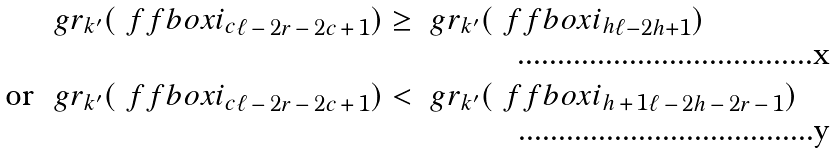<formula> <loc_0><loc_0><loc_500><loc_500>& \ g r _ { k ^ { \prime } } ( \ f f b o x { i _ { c } } _ { \ell \, - \, 2 r \, - \, 2 c \, + \, 1 } ) \geq \ g r _ { k ^ { \prime } } ( \ f f b o x { i _ { h } } _ { \ell - 2 h + 1 } ) \\ \text {or } & \ g r _ { k ^ { \prime } } ( \ f f b o x { i _ { c } } _ { \ell \, - \, 2 r \, - \, 2 c \, + \, 1 } ) < \ g r _ { k ^ { \prime } } ( \ f f b o x { i _ { h \, + \, 1 } } _ { \ell \, - \, 2 h \, - \, 2 r \, - \, 1 } )</formula> 